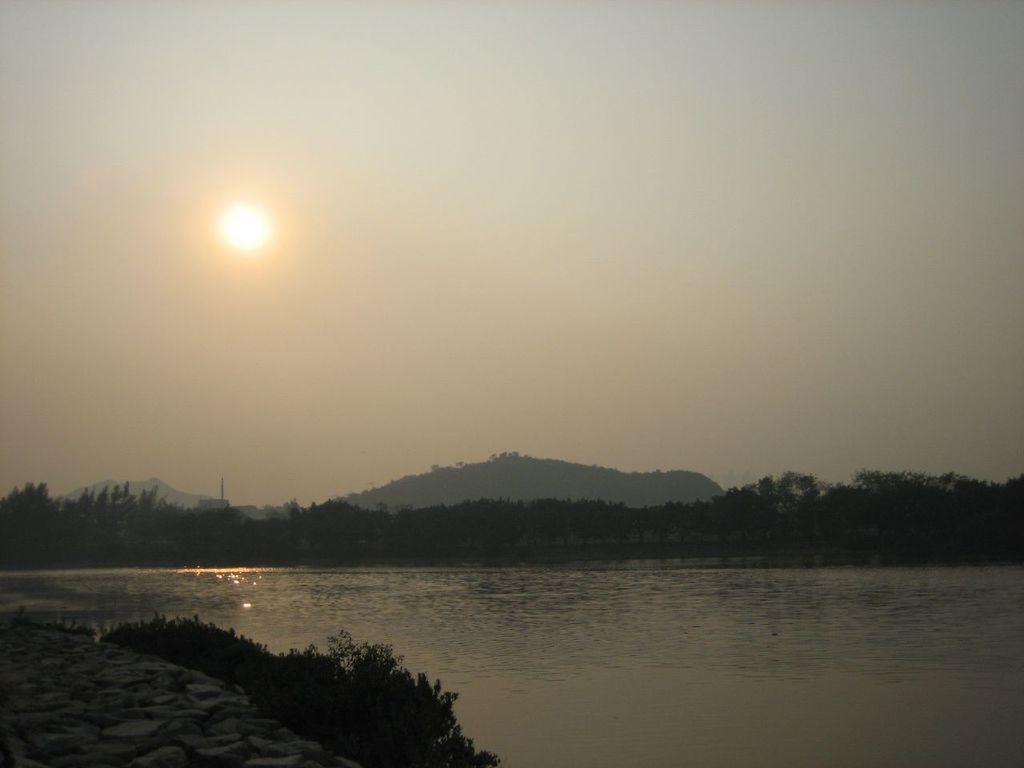What type of environment is depicted in the image? The image is an outside view. What body of water can be seen at the bottom of the image? There is a river at the bottom of the image. What is visible on the left side of the image? There is ground visible on the left side of the image, and there are plants present there as well. What can be seen in the background of the image? There are trees in the background of the image. What type of shop can be seen in the image? There is no shop present in the image; it is an outside view of a river, ground, plants, and trees. Who is the partner of the person standing near the river in the image? There is no person standing near the river in the image, and therefore no partner can be identified. 